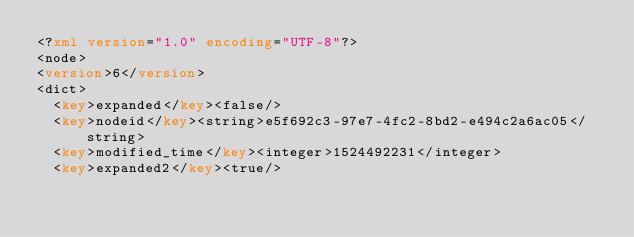<code> <loc_0><loc_0><loc_500><loc_500><_XML_><?xml version="1.0" encoding="UTF-8"?>
<node>
<version>6</version>
<dict>
  <key>expanded</key><false/>
  <key>nodeid</key><string>e5f692c3-97e7-4fc2-8bd2-e494c2a6ac05</string>
  <key>modified_time</key><integer>1524492231</integer>
  <key>expanded2</key><true/></code> 